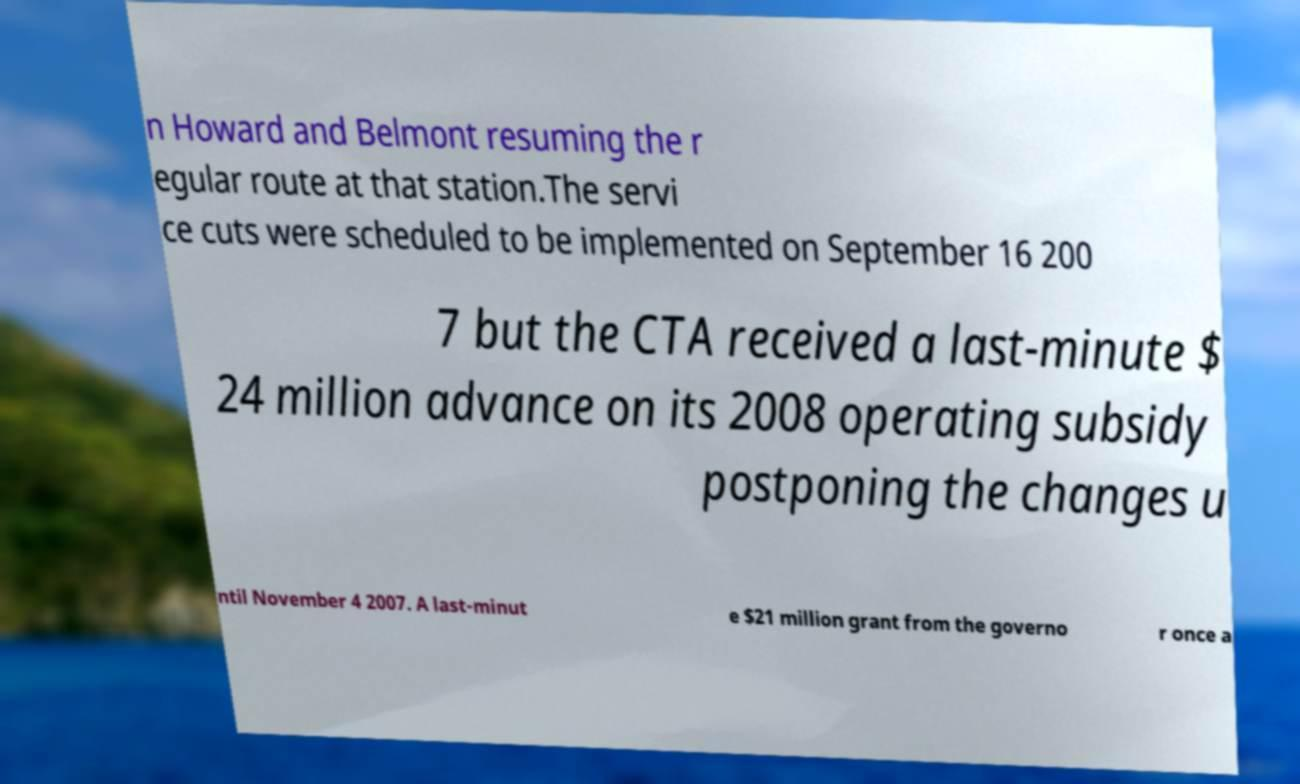Can you read and provide the text displayed in the image?This photo seems to have some interesting text. Can you extract and type it out for me? n Howard and Belmont resuming the r egular route at that station.The servi ce cuts were scheduled to be implemented on September 16 200 7 but the CTA received a last-minute $ 24 million advance on its 2008 operating subsidy postponing the changes u ntil November 4 2007. A last-minut e $21 million grant from the governo r once a 